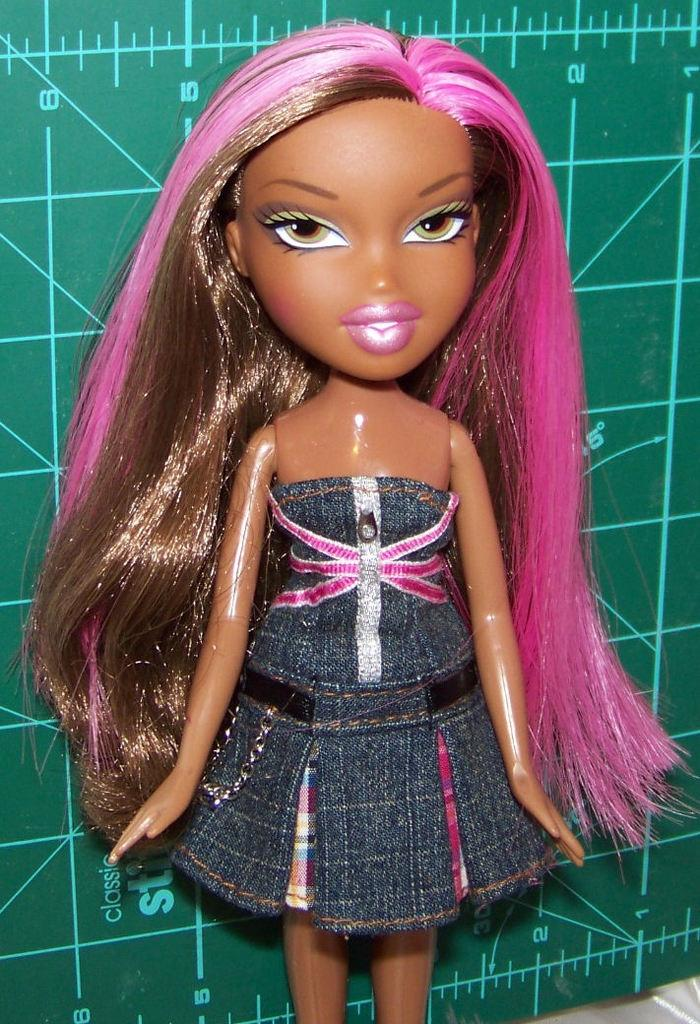What is the main subject of the image? There is a doll of a girl in the image. What can be seen in the background of the image? There is a green color board in the background of the image. What is the appearance of the green color board? The green color board has lines on it. What type of humor can be seen in the image? There is no humor present in the image; it features a doll of a girl and a green color board with lines. What color is the gold band in the image? There is no gold band present in the image. 